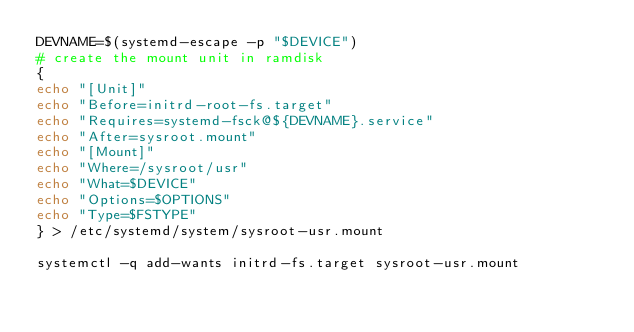Convert code to text. <code><loc_0><loc_0><loc_500><loc_500><_Bash_>DEVNAME=$(systemd-escape -p "$DEVICE")
# create the mount unit in ramdisk
{
echo "[Unit]"
echo "Before=initrd-root-fs.target"
echo "Requires=systemd-fsck@${DEVNAME}.service"
echo "After=sysroot.mount"
echo "[Mount]"
echo "Where=/sysroot/usr"
echo "What=$DEVICE"
echo "Options=$OPTIONS"
echo "Type=$FSTYPE"
} > /etc/systemd/system/sysroot-usr.mount

systemctl -q add-wants initrd-fs.target sysroot-usr.mount
</code> 